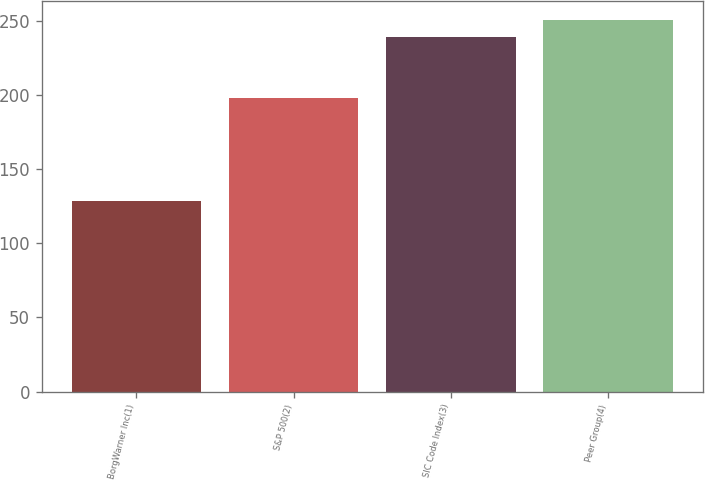Convert chart to OTSL. <chart><loc_0><loc_0><loc_500><loc_500><bar_chart><fcel>BorgWarner Inc(1)<fcel>S&P 500(2)<fcel>SIC Code Index(3)<fcel>Peer Group(4)<nl><fcel>128.74<fcel>198.18<fcel>239.48<fcel>251.03<nl></chart> 